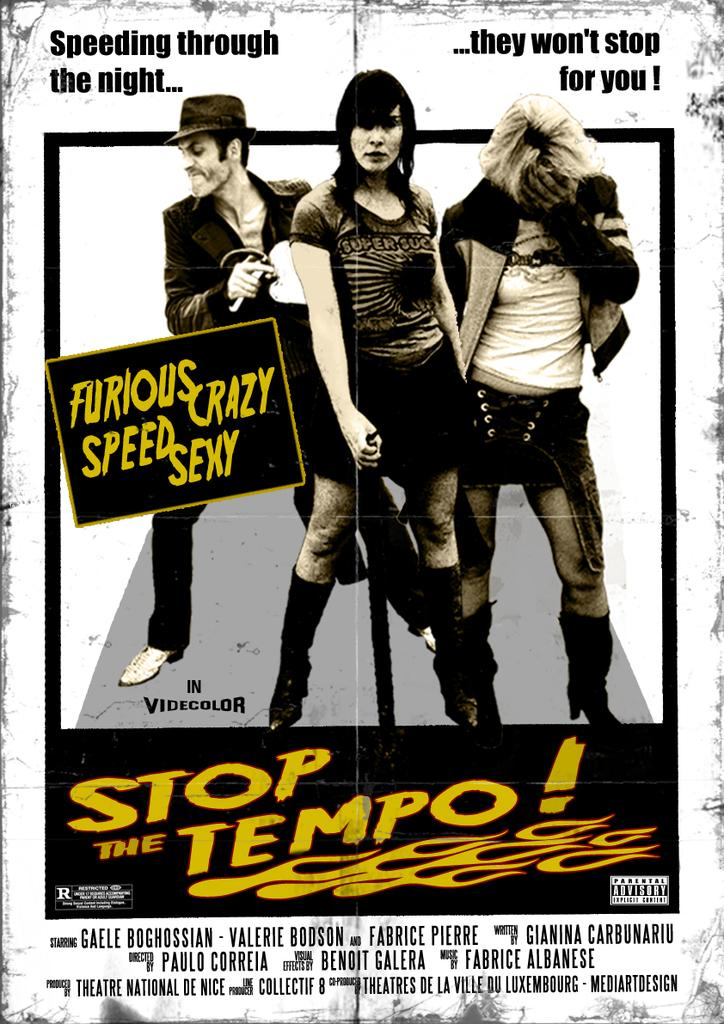What is present in the image? There is a poster in the image. What can be found on the poster? The poster contains text. How many people are depicted on the poster? There are three persons standing on the poster. What type of vegetable is being used as a desk in the image? There is no vegetable or desk present in the image; it only features a poster with text and three persons standing on it. 